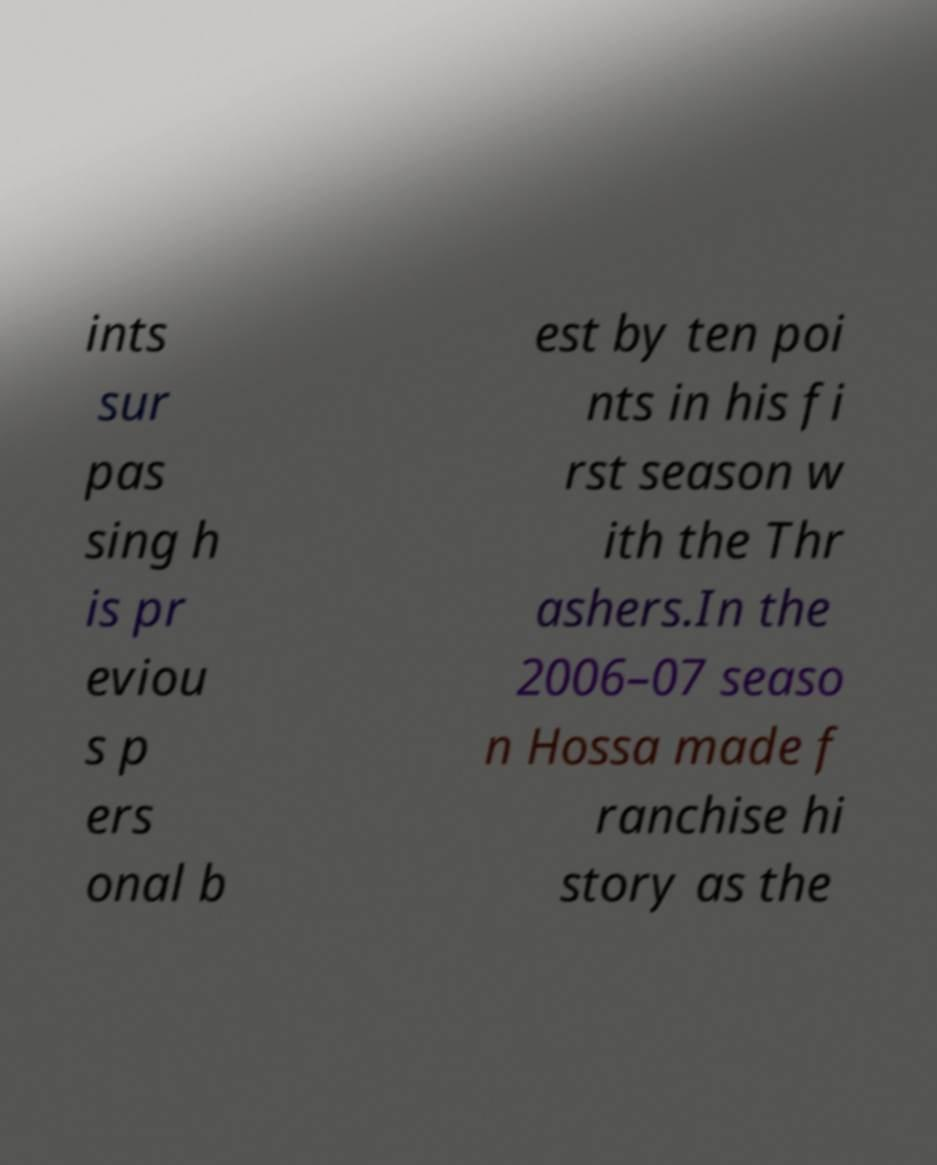What messages or text are displayed in this image? I need them in a readable, typed format. ints sur pas sing h is pr eviou s p ers onal b est by ten poi nts in his fi rst season w ith the Thr ashers.In the 2006–07 seaso n Hossa made f ranchise hi story as the 